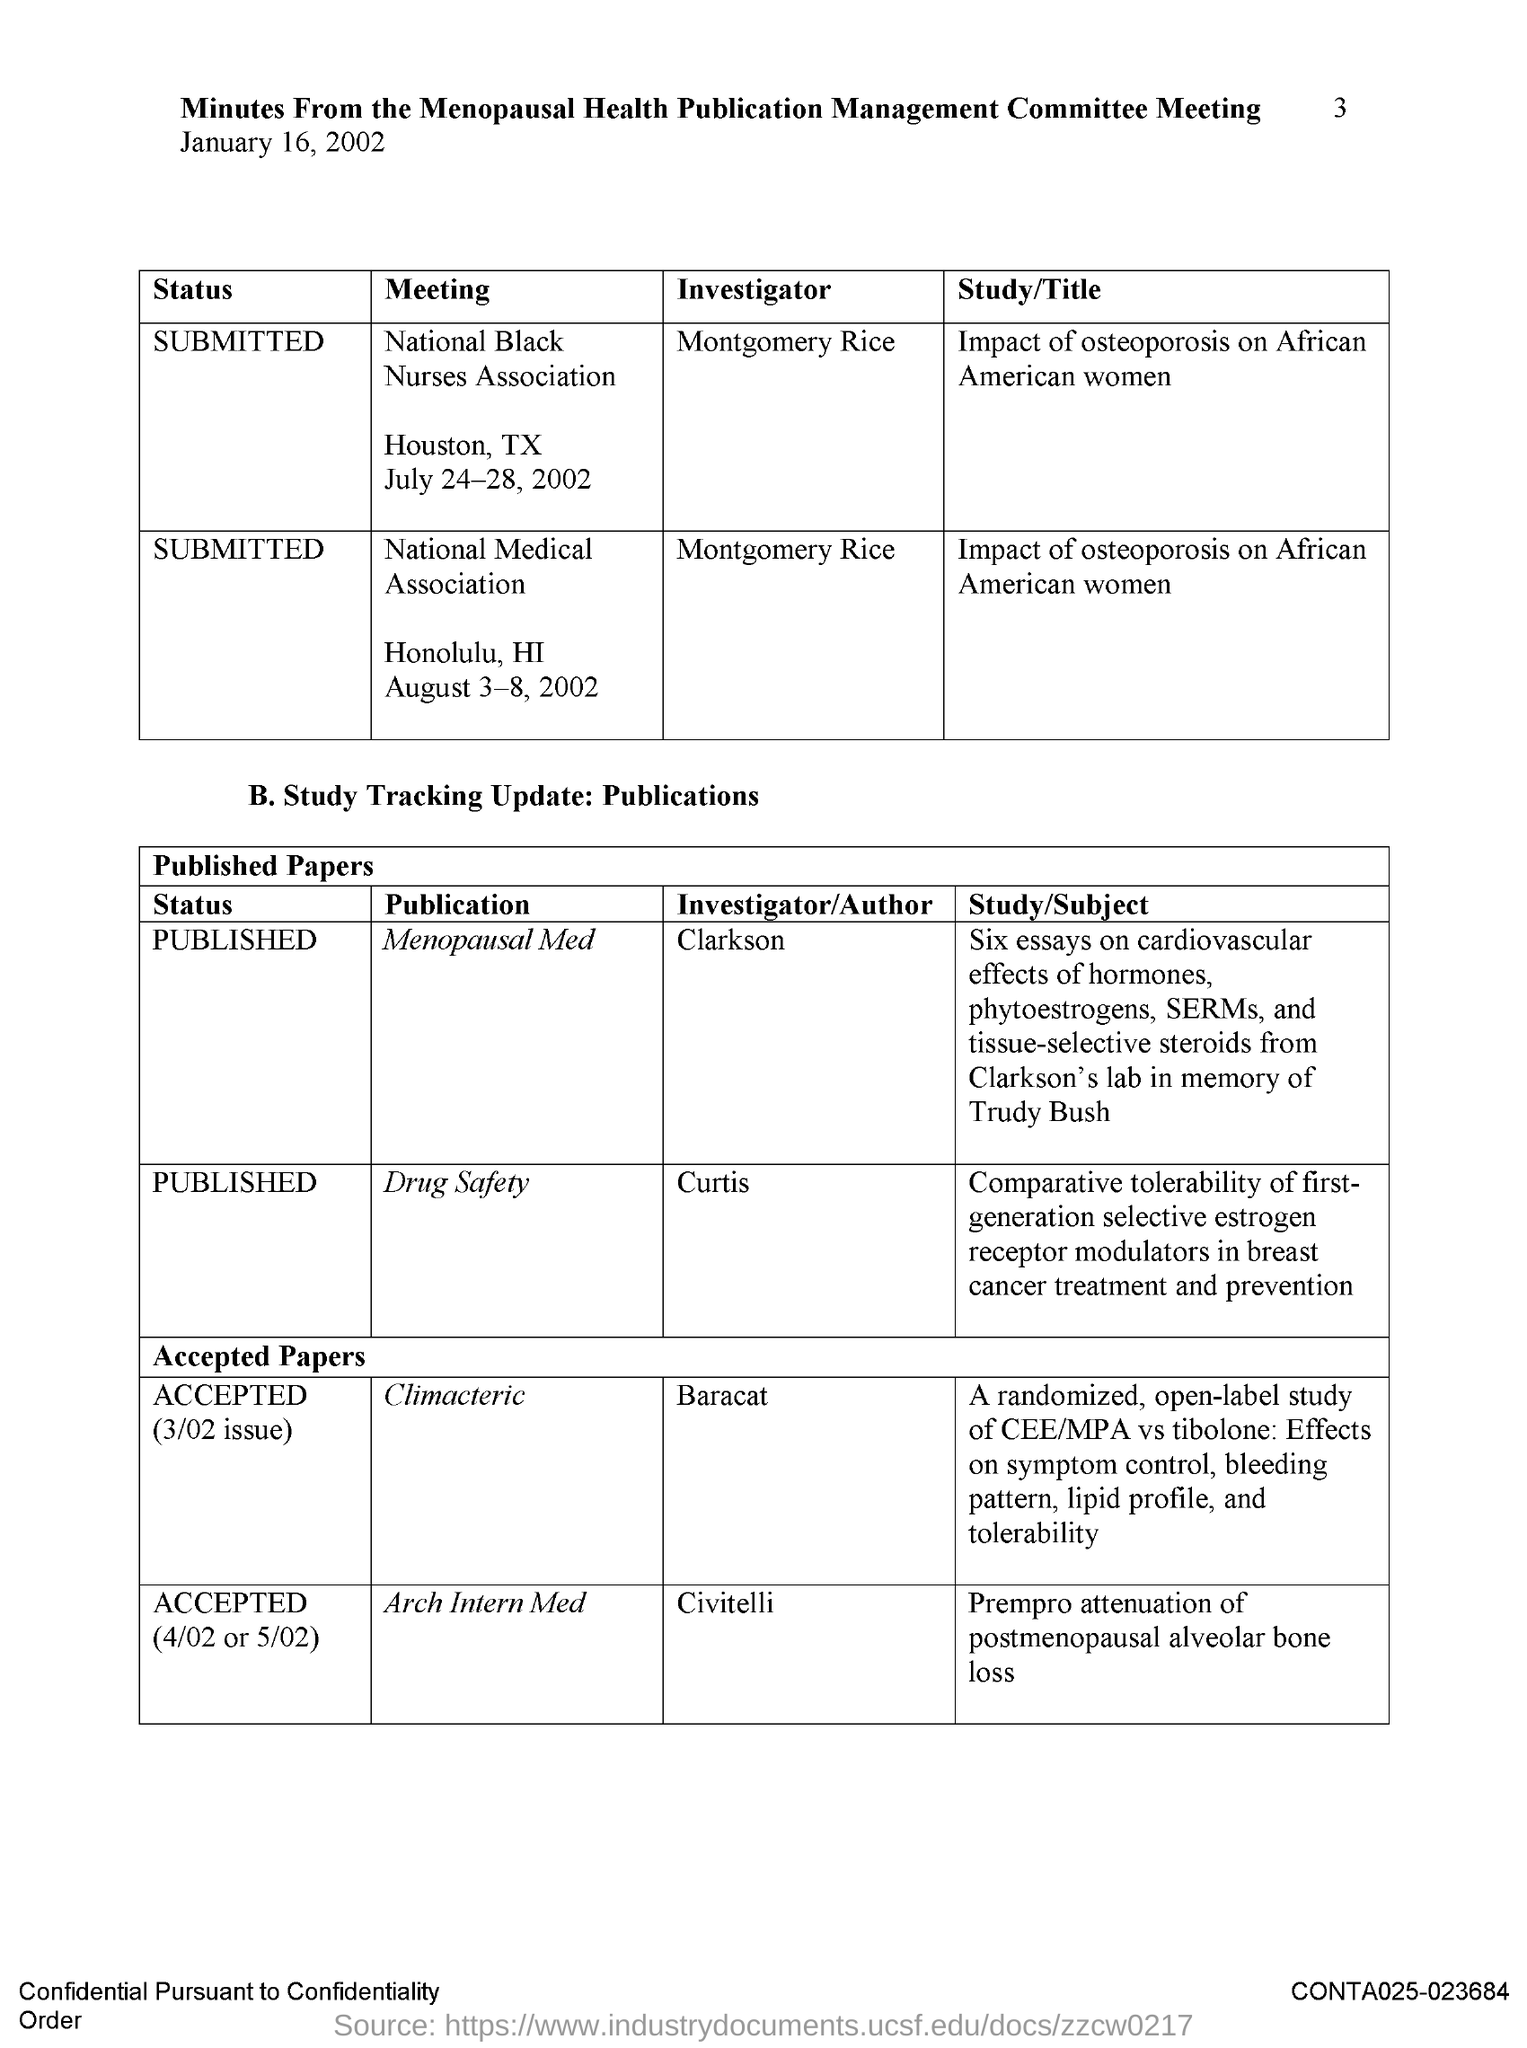List a handful of essential elements in this visual. The investigator for the publication on drug safety is CURTIS. The publication "Climacteric" has an investigator named Baracat who is the investigator for the publication. 